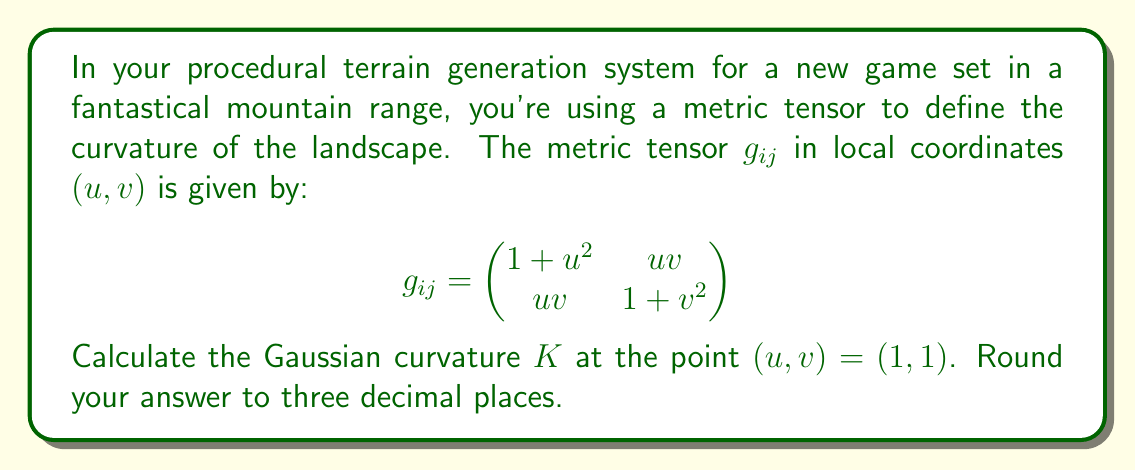Help me with this question. To calculate the Gaussian curvature $K$ using the metric tensor, we'll follow these steps:

1) The Gaussian curvature is given by:

   $$K = \frac{R_{1212}}{g}$$

   where $R_{1212}$ is a component of the Riemann curvature tensor and $g$ is the determinant of the metric tensor.

2) First, let's calculate $g$ at $(1,1)$:

   $$g = \det(g_{ij}) = (1+u^2)(1+v^2) - (uv)^2$$
   $$g_{(1,1)} = (1+1^2)(1+1^2) - (1\cdot1)^2 = 4 - 1 = 3$$

3) Now, we need to calculate $R_{1212}$. The formula for this in terms of the metric tensor is:

   $$R_{1212} = \frac{1}{2}\left(\frac{\partial^2 g_{22}}{\partial u^2} + \frac{\partial^2 g_{11}}{\partial v^2} - 2\frac{\partial^2 g_{12}}{\partial u \partial v}\right) - \frac{1}{4}g^{ij}\left(\frac{\partial g_{1i}}{\partial v} - \frac{\partial g_{1v}}{\partial i}\right)\left(\frac{\partial g_{2j}}{\partial u} - \frac{\partial g_{2u}}{\partial j}\right)$$

4) Let's calculate each term:

   $\frac{\partial^2 g_{22}}{\partial u^2} = 0$
   $\frac{\partial^2 g_{11}}{\partial v^2} = 0$
   $\frac{\partial^2 g_{12}}{\partial u \partial v} = 1$

5) For the second term, we need $g^{ij}$, which is the inverse of $g_{ij}$:

   $$g^{ij} = \frac{1}{g}\begin{pmatrix}
   1+v^2 & -uv \\
   -uv & 1+u^2
   \end{pmatrix}$$

6) Calculating the derivatives:

   $\frac{\partial g_{11}}{\partial v} = 0$, $\frac{\partial g_{12}}{\partial v} = u$
   $\frac{\partial g_{21}}{\partial u} = v$, $\frac{\partial g_{22}}{\partial u} = 0$

7) Substituting these into the formula for $R_{1212}$:

   $$R_{1212} = \frac{1}{2}(0 + 0 - 2) - \frac{1}{4}\left(\frac{1}{3}\begin{pmatrix}
   2 & -1 \\
   -1 & 2
   \end{pmatrix}\right)\begin{pmatrix}
   u & -u \\
   -v & v
   \end{pmatrix}$$

8) Evaluating at $(1,1)$:

   $$R_{1212} = -1 - \frac{1}{4}\left(\frac{1}{3}\begin{pmatrix}
   2 & -1 \\
   -1 & 2
   \end{pmatrix}\right)\begin{pmatrix}
   1 & -1 \\
   -1 & 1
   \end{pmatrix} = -1 - \frac{1}{4}\left(\frac{2}{3}\right) = -\frac{5}{6}$$

9) Finally, we can calculate $K$:

   $$K = \frac{R_{1212}}{g} = \frac{-5/6}{3} = -\frac{5}{18} \approx -0.278$$
Answer: $-0.278$ 